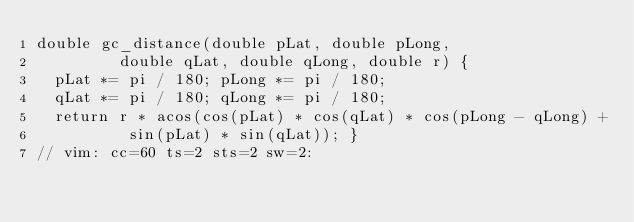Convert code to text. <code><loc_0><loc_0><loc_500><loc_500><_C++_>double gc_distance(double pLat, double pLong,
         double qLat, double qLong, double r) {
  pLat *= pi / 180; pLong *= pi / 180;
  qLat *= pi / 180; qLong *= pi / 180;
  return r * acos(cos(pLat) * cos(qLat) * cos(pLong - qLong) +
          sin(pLat) * sin(qLat)); }
// vim: cc=60 ts=2 sts=2 sw=2:
</code> 